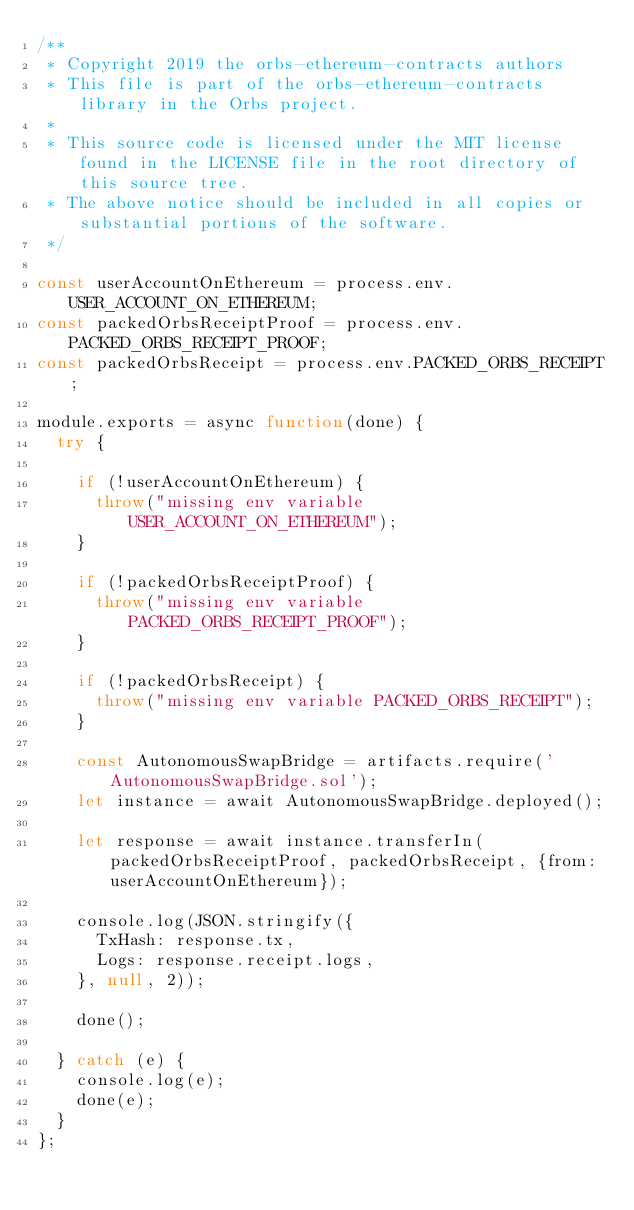<code> <loc_0><loc_0><loc_500><loc_500><_JavaScript_>/**
 * Copyright 2019 the orbs-ethereum-contracts authors
 * This file is part of the orbs-ethereum-contracts library in the Orbs project.
 *
 * This source code is licensed under the MIT license found in the LICENSE file in the root directory of this source tree.
 * The above notice should be included in all copies or substantial portions of the software.
 */

const userAccountOnEthereum = process.env.USER_ACCOUNT_ON_ETHEREUM;
const packedOrbsReceiptProof = process.env.PACKED_ORBS_RECEIPT_PROOF;
const packedOrbsReceipt = process.env.PACKED_ORBS_RECEIPT;

module.exports = async function(done) {
  try {

    if (!userAccountOnEthereum) {
      throw("missing env variable USER_ACCOUNT_ON_ETHEREUM");
    }

    if (!packedOrbsReceiptProof) {
      throw("missing env variable PACKED_ORBS_RECEIPT_PROOF");
    }

    if (!packedOrbsReceipt) {
      throw("missing env variable PACKED_ORBS_RECEIPT");
    }

    const AutonomousSwapBridge = artifacts.require('AutonomousSwapBridge.sol');
    let instance = await AutonomousSwapBridge.deployed();

    let response = await instance.transferIn(packedOrbsReceiptProof, packedOrbsReceipt, {from: userAccountOnEthereum});

    console.log(JSON.stringify({
      TxHash: response.tx,
      Logs: response.receipt.logs,
    }, null, 2));

    done();

  } catch (e) {
    console.log(e);
    done(e);
  }
};
</code> 